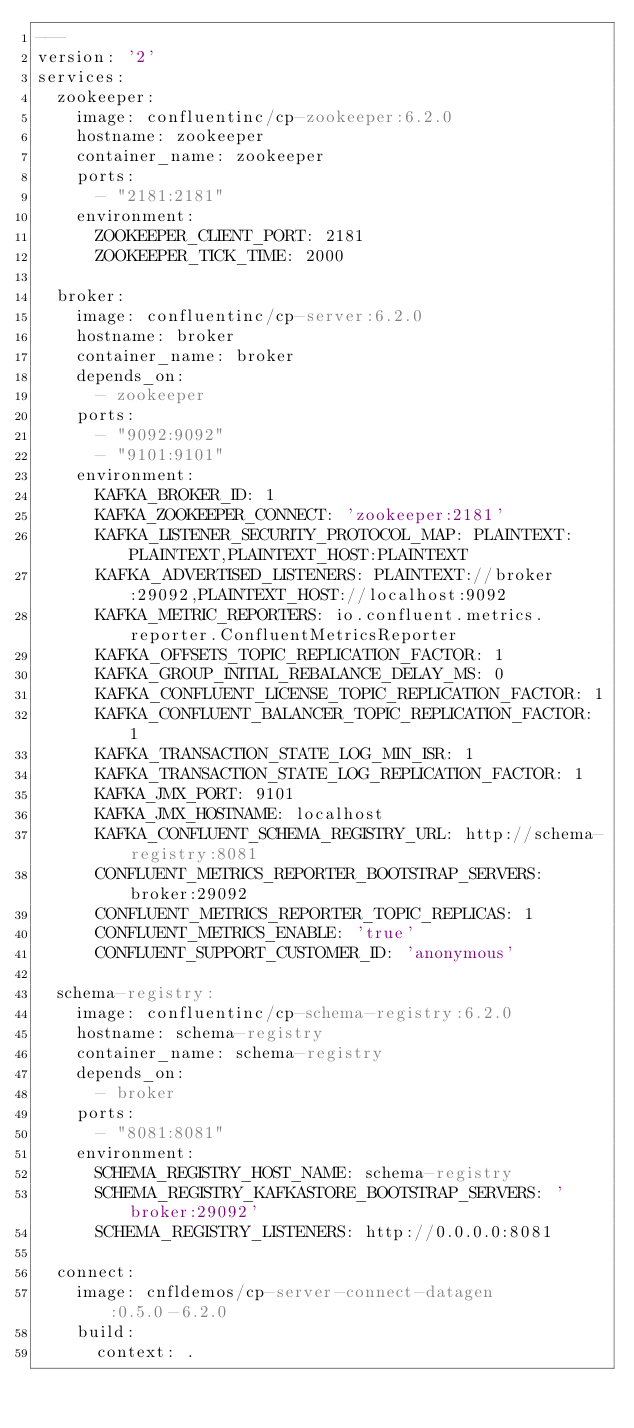Convert code to text. <code><loc_0><loc_0><loc_500><loc_500><_YAML_>---
version: '2'
services:
  zookeeper:
    image: confluentinc/cp-zookeeper:6.2.0
    hostname: zookeeper
    container_name: zookeeper
    ports:
      - "2181:2181"
    environment:
      ZOOKEEPER_CLIENT_PORT: 2181
      ZOOKEEPER_TICK_TIME: 2000

  broker:
    image: confluentinc/cp-server:6.2.0
    hostname: broker
    container_name: broker
    depends_on:
      - zookeeper
    ports:
      - "9092:9092"
      - "9101:9101"
    environment:
      KAFKA_BROKER_ID: 1
      KAFKA_ZOOKEEPER_CONNECT: 'zookeeper:2181'
      KAFKA_LISTENER_SECURITY_PROTOCOL_MAP: PLAINTEXT:PLAINTEXT,PLAINTEXT_HOST:PLAINTEXT
      KAFKA_ADVERTISED_LISTENERS: PLAINTEXT://broker:29092,PLAINTEXT_HOST://localhost:9092
      KAFKA_METRIC_REPORTERS: io.confluent.metrics.reporter.ConfluentMetricsReporter
      KAFKA_OFFSETS_TOPIC_REPLICATION_FACTOR: 1
      KAFKA_GROUP_INITIAL_REBALANCE_DELAY_MS: 0
      KAFKA_CONFLUENT_LICENSE_TOPIC_REPLICATION_FACTOR: 1
      KAFKA_CONFLUENT_BALANCER_TOPIC_REPLICATION_FACTOR: 1
      KAFKA_TRANSACTION_STATE_LOG_MIN_ISR: 1
      KAFKA_TRANSACTION_STATE_LOG_REPLICATION_FACTOR: 1
      KAFKA_JMX_PORT: 9101
      KAFKA_JMX_HOSTNAME: localhost
      KAFKA_CONFLUENT_SCHEMA_REGISTRY_URL: http://schema-registry:8081
      CONFLUENT_METRICS_REPORTER_BOOTSTRAP_SERVERS: broker:29092
      CONFLUENT_METRICS_REPORTER_TOPIC_REPLICAS: 1
      CONFLUENT_METRICS_ENABLE: 'true'
      CONFLUENT_SUPPORT_CUSTOMER_ID: 'anonymous'

  schema-registry:
    image: confluentinc/cp-schema-registry:6.2.0
    hostname: schema-registry
    container_name: schema-registry
    depends_on:
      - broker
    ports:
      - "8081:8081"
    environment:
      SCHEMA_REGISTRY_HOST_NAME: schema-registry
      SCHEMA_REGISTRY_KAFKASTORE_BOOTSTRAP_SERVERS: 'broker:29092'
      SCHEMA_REGISTRY_LISTENERS: http://0.0.0.0:8081

  connect:
    image: cnfldemos/cp-server-connect-datagen:0.5.0-6.2.0
    build:
      context: .</code> 